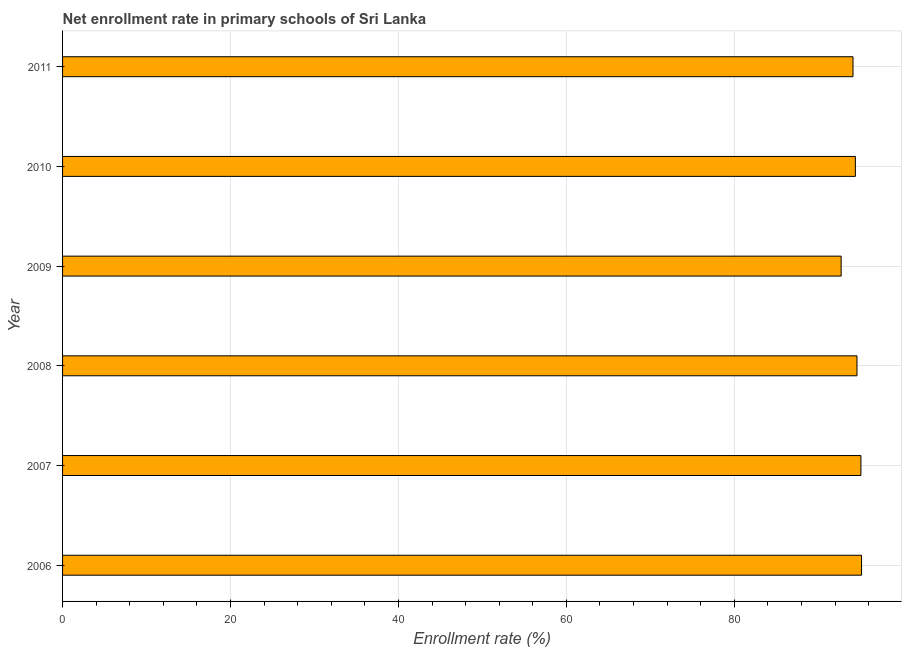Does the graph contain grids?
Provide a short and direct response. Yes. What is the title of the graph?
Provide a short and direct response. Net enrollment rate in primary schools of Sri Lanka. What is the label or title of the X-axis?
Your response must be concise. Enrollment rate (%). What is the label or title of the Y-axis?
Provide a succinct answer. Year. What is the net enrollment rate in primary schools in 2010?
Provide a succinct answer. 94.42. Across all years, what is the maximum net enrollment rate in primary schools?
Provide a succinct answer. 95.15. Across all years, what is the minimum net enrollment rate in primary schools?
Provide a short and direct response. 92.72. In which year was the net enrollment rate in primary schools maximum?
Offer a very short reply. 2006. What is the sum of the net enrollment rate in primary schools?
Give a very brief answer. 566.12. What is the difference between the net enrollment rate in primary schools in 2006 and 2009?
Make the answer very short. 2.43. What is the average net enrollment rate in primary schools per year?
Make the answer very short. 94.35. What is the median net enrollment rate in primary schools?
Make the answer very short. 94.51. Do a majority of the years between 2006 and 2010 (inclusive) have net enrollment rate in primary schools greater than 88 %?
Provide a succinct answer. Yes. What is the difference between the highest and the second highest net enrollment rate in primary schools?
Provide a short and direct response. 0.07. What is the difference between the highest and the lowest net enrollment rate in primary schools?
Make the answer very short. 2.43. In how many years, is the net enrollment rate in primary schools greater than the average net enrollment rate in primary schools taken over all years?
Your answer should be very brief. 4. How many bars are there?
Provide a short and direct response. 6. How many years are there in the graph?
Provide a short and direct response. 6. Are the values on the major ticks of X-axis written in scientific E-notation?
Offer a terse response. No. What is the Enrollment rate (%) of 2006?
Provide a short and direct response. 95.15. What is the Enrollment rate (%) of 2007?
Offer a terse response. 95.08. What is the Enrollment rate (%) in 2008?
Give a very brief answer. 94.61. What is the Enrollment rate (%) of 2009?
Provide a succinct answer. 92.72. What is the Enrollment rate (%) in 2010?
Offer a very short reply. 94.42. What is the Enrollment rate (%) of 2011?
Give a very brief answer. 94.14. What is the difference between the Enrollment rate (%) in 2006 and 2007?
Make the answer very short. 0.07. What is the difference between the Enrollment rate (%) in 2006 and 2008?
Ensure brevity in your answer.  0.54. What is the difference between the Enrollment rate (%) in 2006 and 2009?
Make the answer very short. 2.43. What is the difference between the Enrollment rate (%) in 2006 and 2010?
Your response must be concise. 0.74. What is the difference between the Enrollment rate (%) in 2006 and 2011?
Offer a very short reply. 1.02. What is the difference between the Enrollment rate (%) in 2007 and 2008?
Provide a short and direct response. 0.47. What is the difference between the Enrollment rate (%) in 2007 and 2009?
Provide a succinct answer. 2.36. What is the difference between the Enrollment rate (%) in 2007 and 2010?
Your answer should be compact. 0.66. What is the difference between the Enrollment rate (%) in 2007 and 2011?
Offer a terse response. 0.94. What is the difference between the Enrollment rate (%) in 2008 and 2009?
Offer a very short reply. 1.89. What is the difference between the Enrollment rate (%) in 2008 and 2010?
Ensure brevity in your answer.  0.19. What is the difference between the Enrollment rate (%) in 2008 and 2011?
Make the answer very short. 0.47. What is the difference between the Enrollment rate (%) in 2009 and 2010?
Keep it short and to the point. -1.69. What is the difference between the Enrollment rate (%) in 2009 and 2011?
Your answer should be compact. -1.41. What is the difference between the Enrollment rate (%) in 2010 and 2011?
Your answer should be very brief. 0.28. What is the ratio of the Enrollment rate (%) in 2006 to that in 2008?
Offer a very short reply. 1.01. What is the ratio of the Enrollment rate (%) in 2006 to that in 2009?
Offer a terse response. 1.03. What is the ratio of the Enrollment rate (%) in 2006 to that in 2010?
Keep it short and to the point. 1.01. What is the ratio of the Enrollment rate (%) in 2007 to that in 2008?
Offer a terse response. 1. What is the ratio of the Enrollment rate (%) in 2007 to that in 2011?
Give a very brief answer. 1.01. What is the ratio of the Enrollment rate (%) in 2008 to that in 2009?
Give a very brief answer. 1.02. What is the ratio of the Enrollment rate (%) in 2008 to that in 2010?
Your response must be concise. 1. What is the ratio of the Enrollment rate (%) in 2009 to that in 2011?
Ensure brevity in your answer.  0.98. 